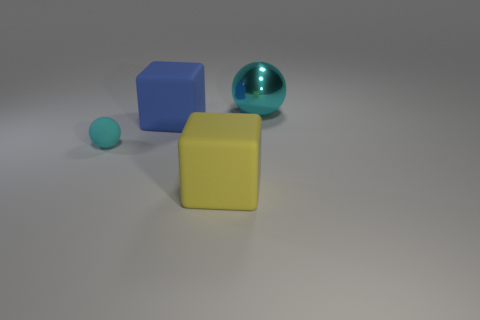The objects seem to be of different sizes, can you compare them? Indeed, there are varying scales here. The blue cube and the metallic sphere are very close in size, creating a visually appealing composition. The yellow cube is the largest object, providing a sense of balance in the image. The small cyan sphere, on the other hand, is the smallest, adding a touch of contrast to the scene. Do the objects tell us anything about the lighting or perspective? Certainly. The softly diffused shadows cast by the objects suggest a light source coming from the upper left side of the image. This lighting creates gentle gradients on the surfaces and helps define the three-dimensional forms. The perspective is head-on, with a slight elevation, allowing each object to be distinct and recognizable. 